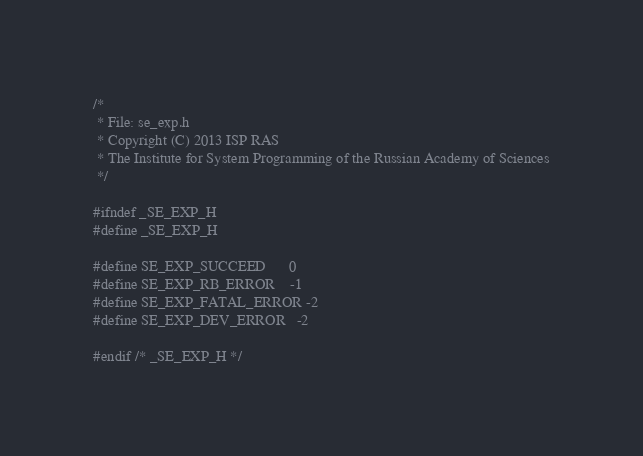<code> <loc_0><loc_0><loc_500><loc_500><_C_>/*
 * File: se_exp.h
 * Copyright (C) 2013 ISP RAS
 * The Institute for System Programming of the Russian Academy of Sciences
 */

#ifndef _SE_EXP_H
#define _SE_EXP_H

#define SE_EXP_SUCCEED      0
#define SE_EXP_RB_ERROR    -1
#define SE_EXP_FATAL_ERROR -2
#define SE_EXP_DEV_ERROR   -2

#endif /* _SE_EXP_H */
</code> 